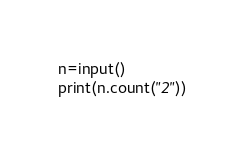<code> <loc_0><loc_0><loc_500><loc_500><_Python_>n=input()
print(n.count("2"))
</code> 